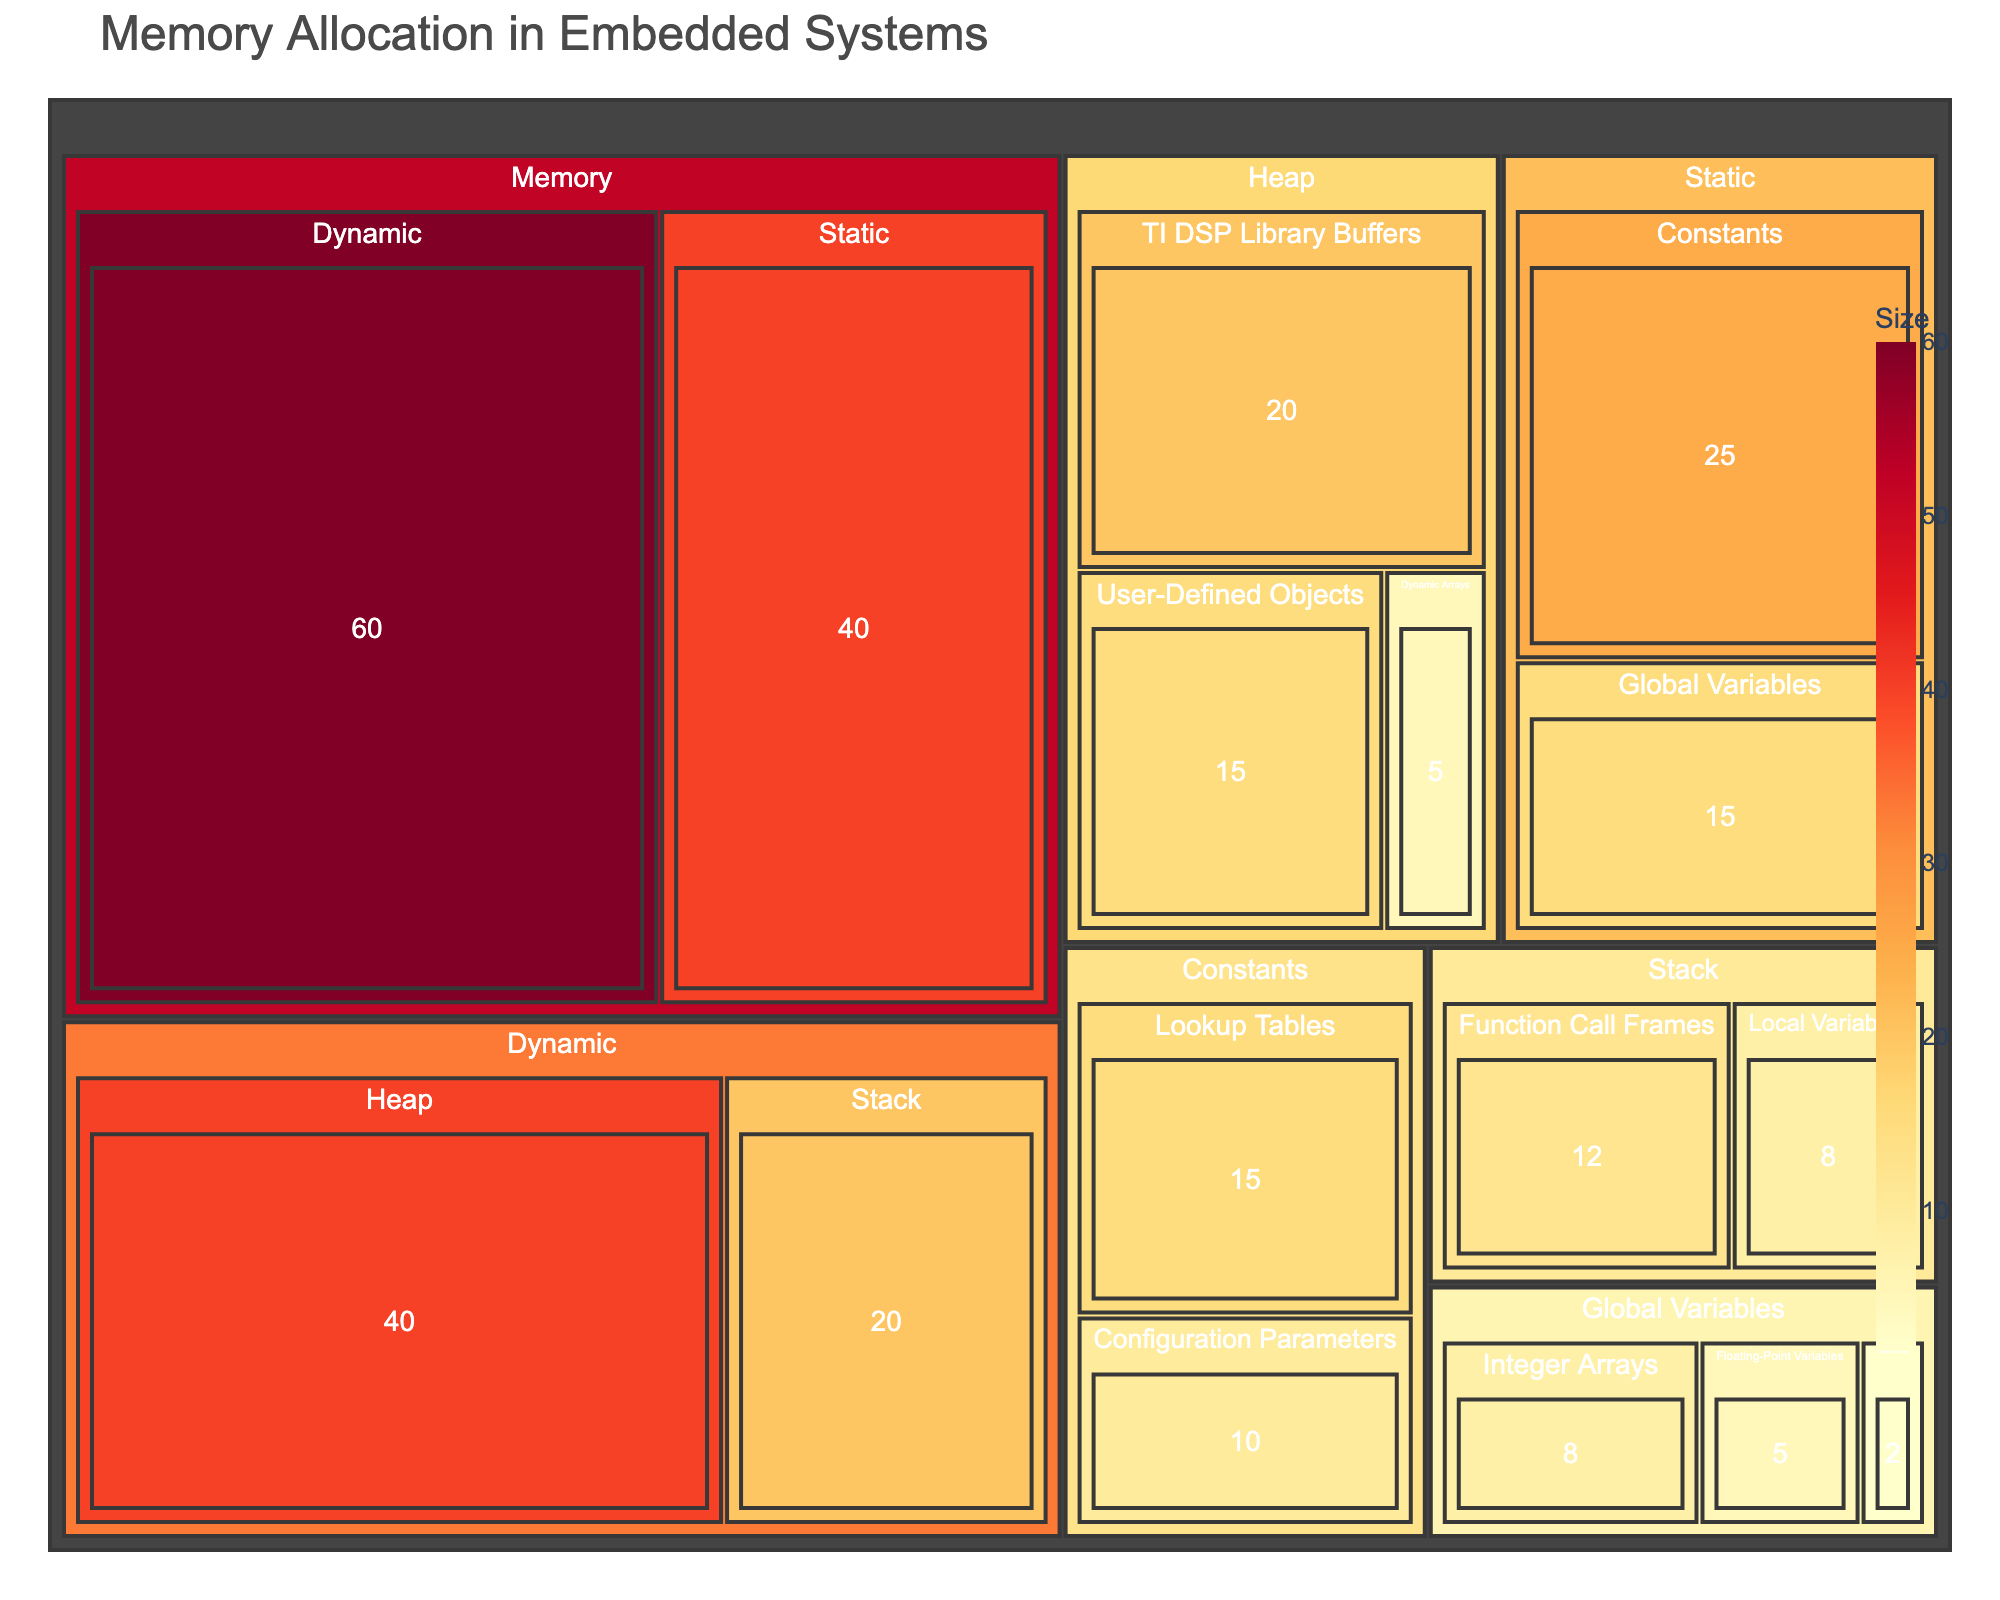What's the title of the figure? The title is typically displayed at the top of the figure in a larger font size. In this case, it is "Memory Allocation in Embedded Systems."
Answer: Memory Allocation in Embedded Systems What does the color of each section represent? The color represents the size of memory allocated to each type or category. The intensity of the color (ranging from yellow to red) indicates the size; darker colors signify larger sizes.
Answer: Size of memory allocation How much memory is allocated for the 'Heap' within 'Dynamic'? The size of each section is typically displayed within the section. In the figure, 'Heap' under 'Dynamic' has an allocation of 40 units.
Answer: 40 What is the smallest memory allocation within 'Global Variables'? By examining the sizes displayed within each 'Global Variables' section, you can see that 'Character Arrays' has the smallest allocation of 2 units.
Answer: 2 Which type under 'Memory' has the largest memory allocation? You can compare the sizes of 'Static' and 'Dynamic' under 'Memory'. 'Dynamic' is 60, which is larger than 'Static' at 40.
Answer: Dynamic What is the combined memory allocation for 'Lookup Tables' and 'Constants'? The memory allocation for 'Lookup Tables' is 15, and for 'Configuration Parameters' under 'Constants', it is 10. Summing these up gives 15 + 10 = 25.
Answer: 25 Compare the memory allocated to 'TI DSP Library Buffers' and 'User-Defined Objects' within the 'Heap'. Which one is larger? 'TI DSP Library Buffers' has an allocation of 20 units, while 'User-Defined Objects' has 15 units. Comparing the two, 'TI DSP Library Buffers' is larger.
Answer: TI DSP Library Buffers How is the memory allocated for 'Function Call Frames' different from 'Local Variables'? Both are types under 'Stack.' 'Function Call Frames' has an allocation of 12 units and 'Local Variables' has 8 units. The difference is 12 - 8 = 4.
Answer: 4 What is the total memory allocated to all 'Global Variables'? Summing up the memory for 'Integer Arrays' (8), 'Floating-Point Variables' (5), and 'Character Arrays' (2) gives 8 + 5 + 2 = 15.
Answer: 15 What is the proportion of memory allocated to 'Configuration Parameters' compared to total 'Constants'? The total memory for 'Constants' is 25 (15 for Lookup Tables, 10 for Configuration Parameters). The proportion for 'Configuration Parameters' is 10/25.
Answer: 0.4 or 40% 